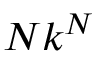Convert formula to latex. <formula><loc_0><loc_0><loc_500><loc_500>N k ^ { N }</formula> 